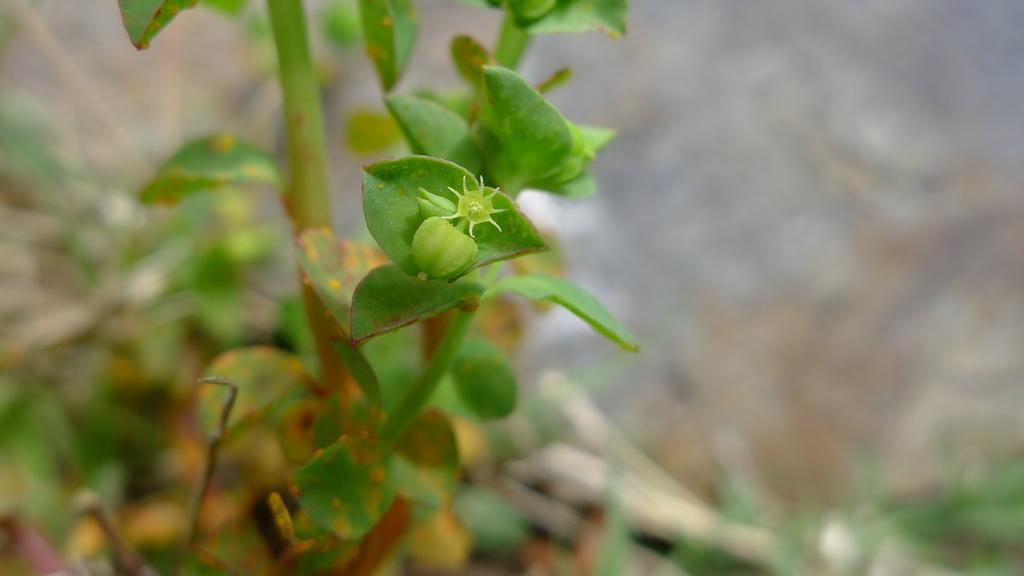What is the main subject of the image? There is a plant in the image. Can you describe the background of the image? The background of the image is blurred. What type of action is the plant taking in the image? The plant is not taking any action in the image, as it is an inanimate object. What type of destruction can be seen in the image? There is no destruction present in the image; it features a plant and a blurred background. 